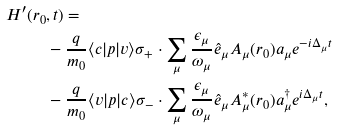Convert formula to latex. <formula><loc_0><loc_0><loc_500><loc_500>H ^ { \prime } ( r _ { 0 } & , t ) = \\ & - \frac { q } { m _ { 0 } } \langle c | p | v \rangle \sigma _ { + } \cdot \sum _ { \mu } \frac { \epsilon _ { \mu } } { \omega _ { \mu } } \hat { e } _ { \mu } A _ { \mu } ( r _ { 0 } ) a _ { \mu } e ^ { - i \Delta _ { \mu } t } \\ & - \frac { q } { m _ { 0 } } \langle v | p | c \rangle \sigma _ { - } \cdot \sum _ { \mu } \frac { \epsilon _ { \mu } } { \omega _ { \mu } } \hat { e } _ { \mu } A ^ { \ast } _ { \mu } ( r _ { 0 } ) a ^ { \dagger } _ { \mu } e ^ { i \Delta _ { \mu } t } ,</formula> 